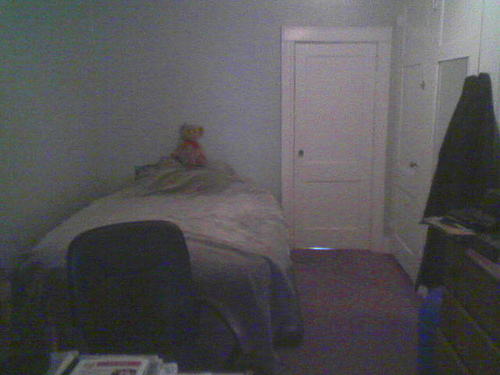<image>What kind of lighting is shown? The kind of lighting in the image is unclear. It could be dim, night vision, natural, low, none or moonlight. What kind of lighting is shown? I don't know what kind of lighting is shown. It can be dim, night vision, natural, low or none. 